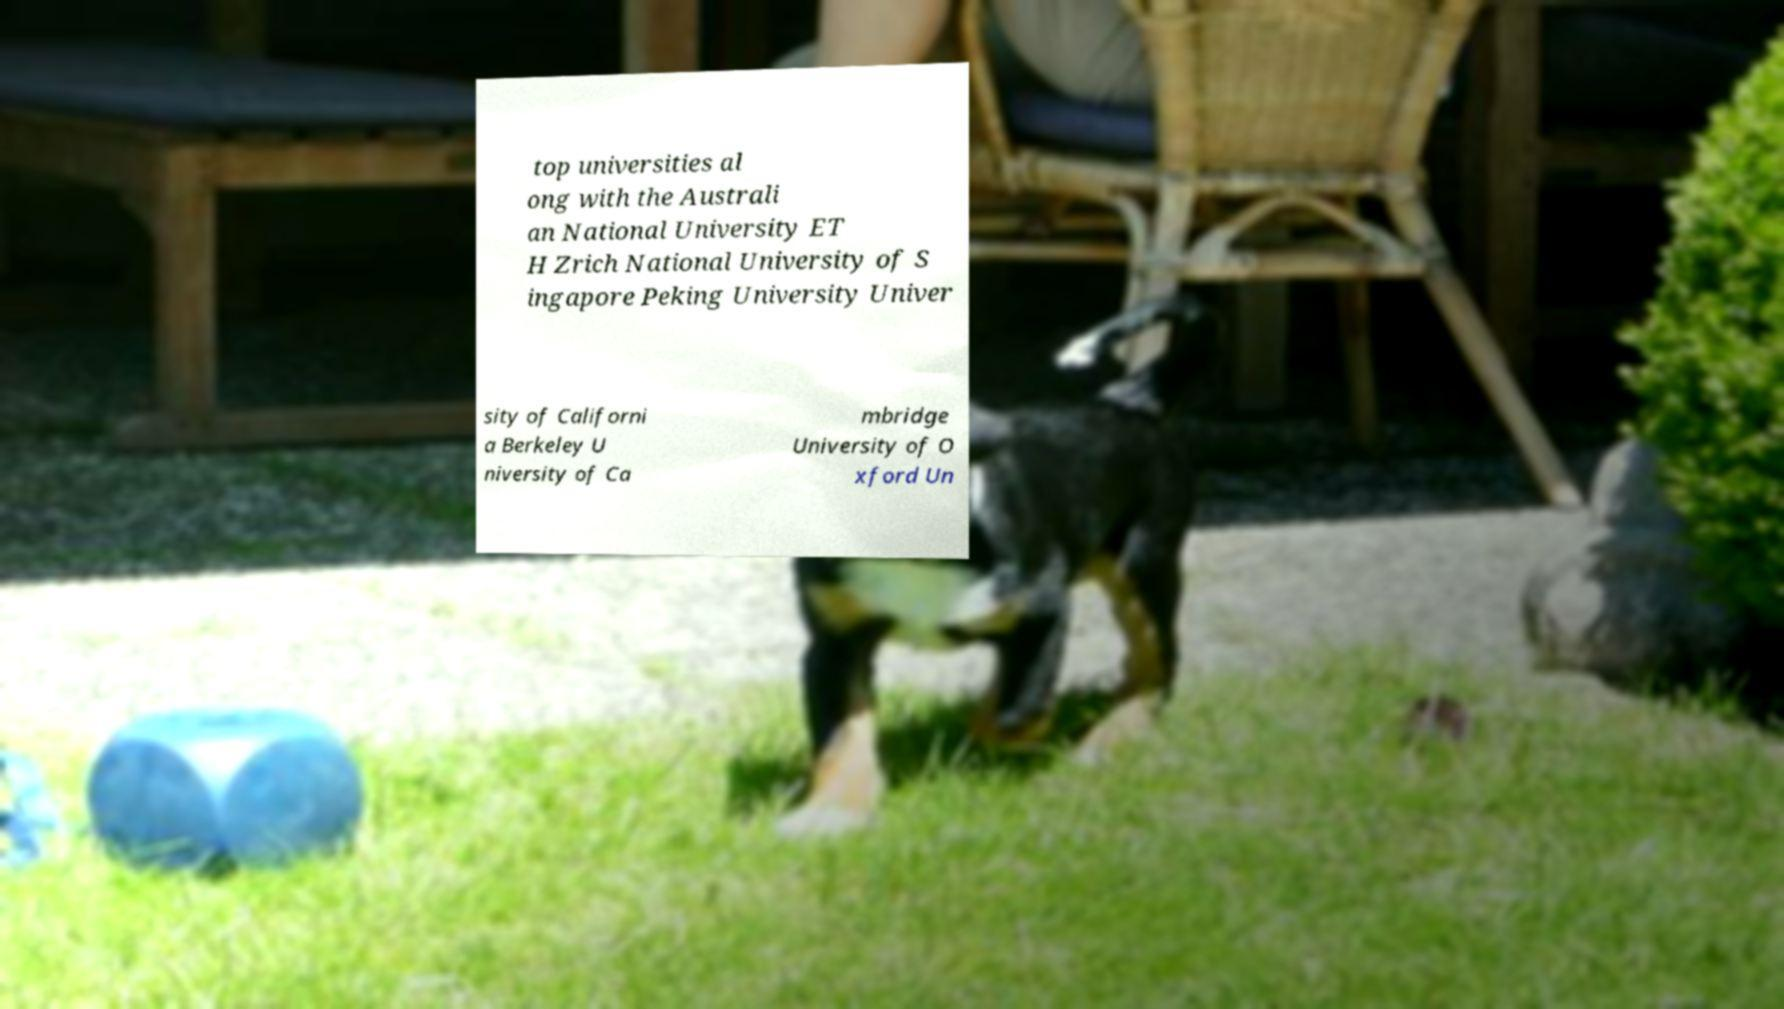Could you assist in decoding the text presented in this image and type it out clearly? top universities al ong with the Australi an National University ET H Zrich National University of S ingapore Peking University Univer sity of Californi a Berkeley U niversity of Ca mbridge University of O xford Un 